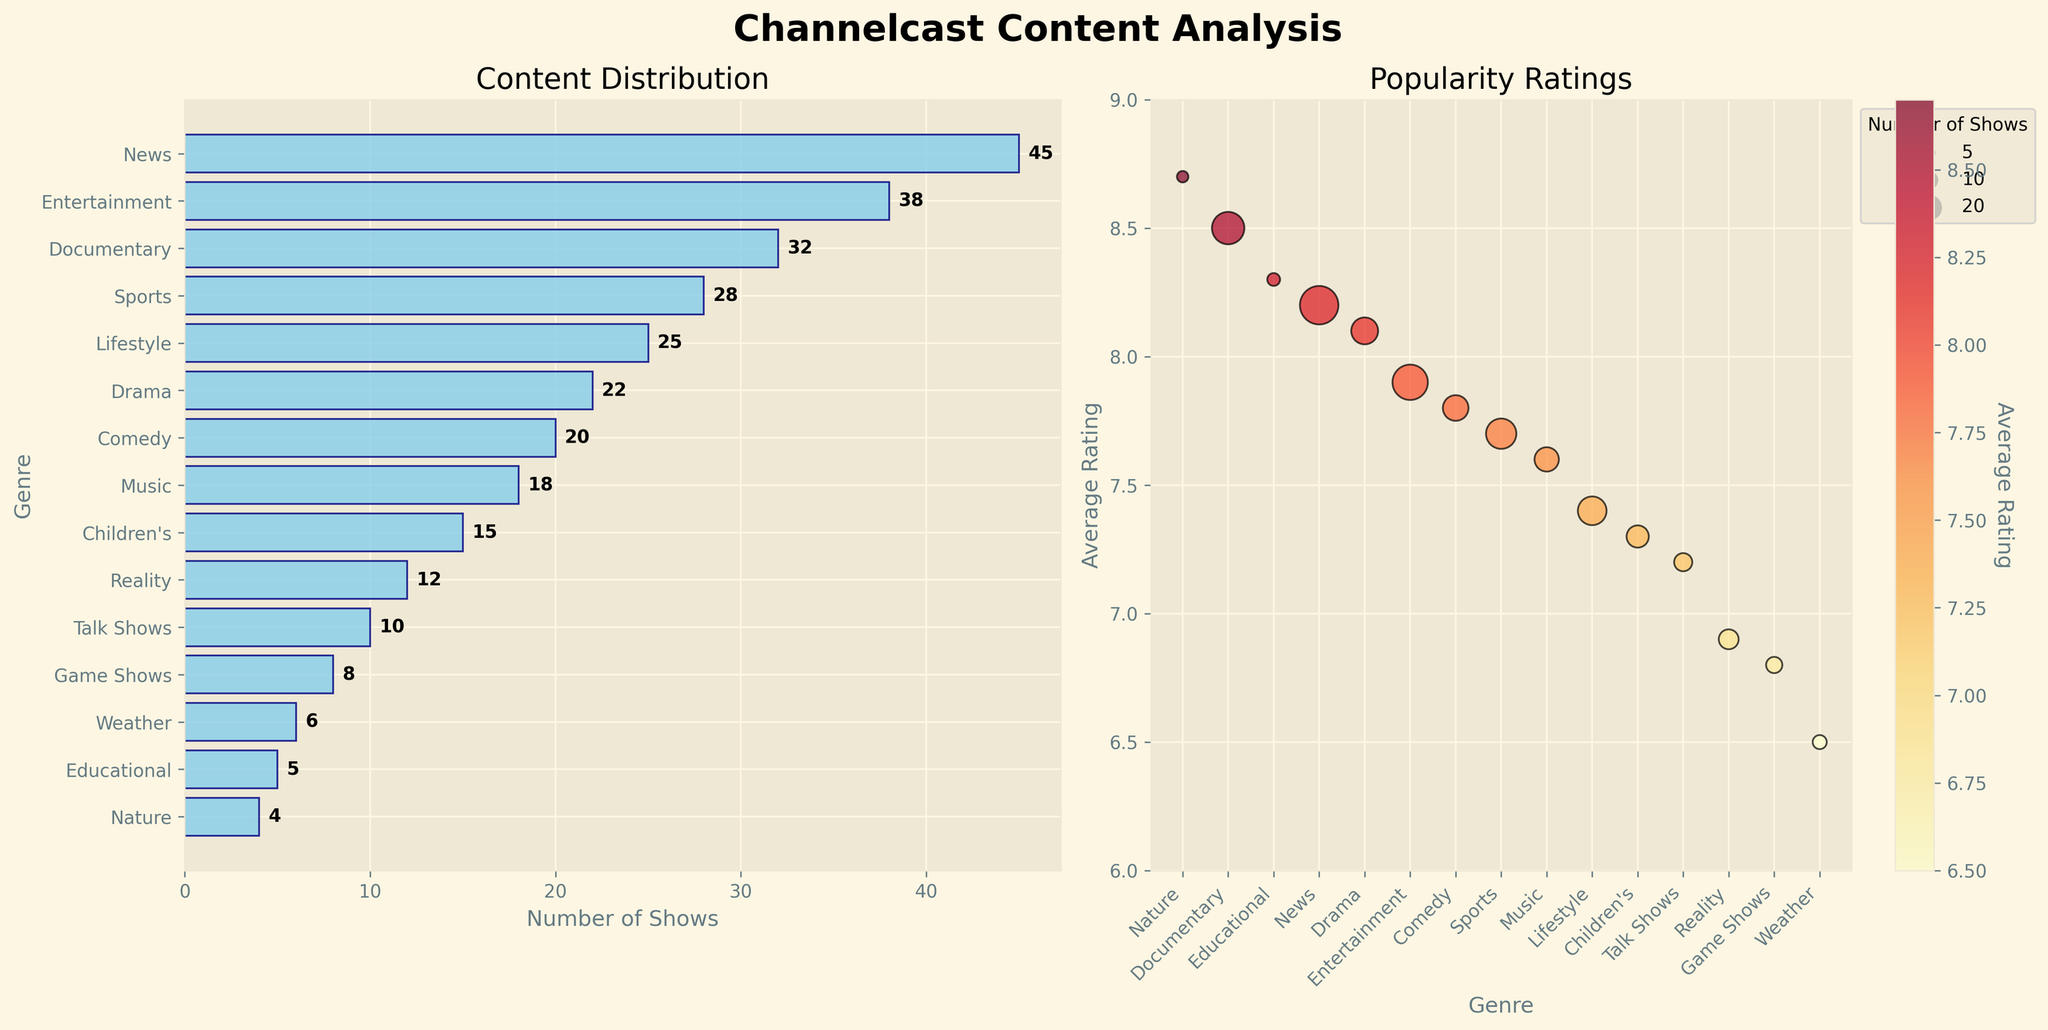What genre has the highest count of shows? By examining the bar plot of content distribution, the longest bar corresponds to the 'News' genre, indicating it has the highest count of shows.
Answer: News How many genres have an average rating of 8.0 or higher? Refer to the popularity ratings scatter plot and count the genres with ratings of 8.0 or more. These genres are News, Documentary, Drama, Educational, and Nature.
Answer: 5 Which genre has the lowest popularity rating, and what is its value? By looking at the scatter plot for average ratings, the 'Weather' genre is positioned the lowest, indicating it has the lowest rating. Its value is 6.5.
Answer: Weather, 6.5 What is the total count of shows across all genres? Sum all the counts from the content distribution bar plot. The values are 45 + 38 + 32 + 28 + 25 + 22 + 20 + 18 + 15 + 12 + 10 + 8 + 6 + 5 + 4 = 288.
Answer: 288 Which genre has the largest bubble size in the popularity ratings scatter plot? The 'News' genre has the largest bubble in the scatter plot, indicating it has the largest count of shows.
Answer: News Compare the average rating of 'News' and 'Lifestyle'. Which one is higher and by how much? From the scatter plot, 'News' has an average rating of 8.2 and 'Lifestyle' has an average rating of 7.4. The difference is 8.2 - 7.4 = 0.8.
Answer: News, by 0.8 Which genre has the highest average rating, and what is its count of shows? By reviewing the scatter plot and rating values, the 'Nature' genre has the highest average rating of 8.7. The content distribution shows it has 4 shows.
Answer: Nature, 4 How many genres have fewer than 10 shows? Identify the bars in the content distribution plot that are shorter than the 10 mark. These genres are Weather, Educational, Nature, Talk Shows, Game Shows, and Reality.
Answer: 6 What is the difference in the average rating between 'Comedy' and 'Game Shows'? From the scatter plot, 'Comedy' has a rating of 7.8, and 'Game Shows' have a rating of 6.8. The difference is 7.8 - 6.8 = 1.0.
Answer: 1.0 Which genre has a higher average rating: 'Sports' or 'Music'? According to the scatter plot, 'Sports' has an average rating of 7.7 and 'Music' has a rating of 7.6. Thus, 'Sports' has a higher rating.
Answer: Sports 